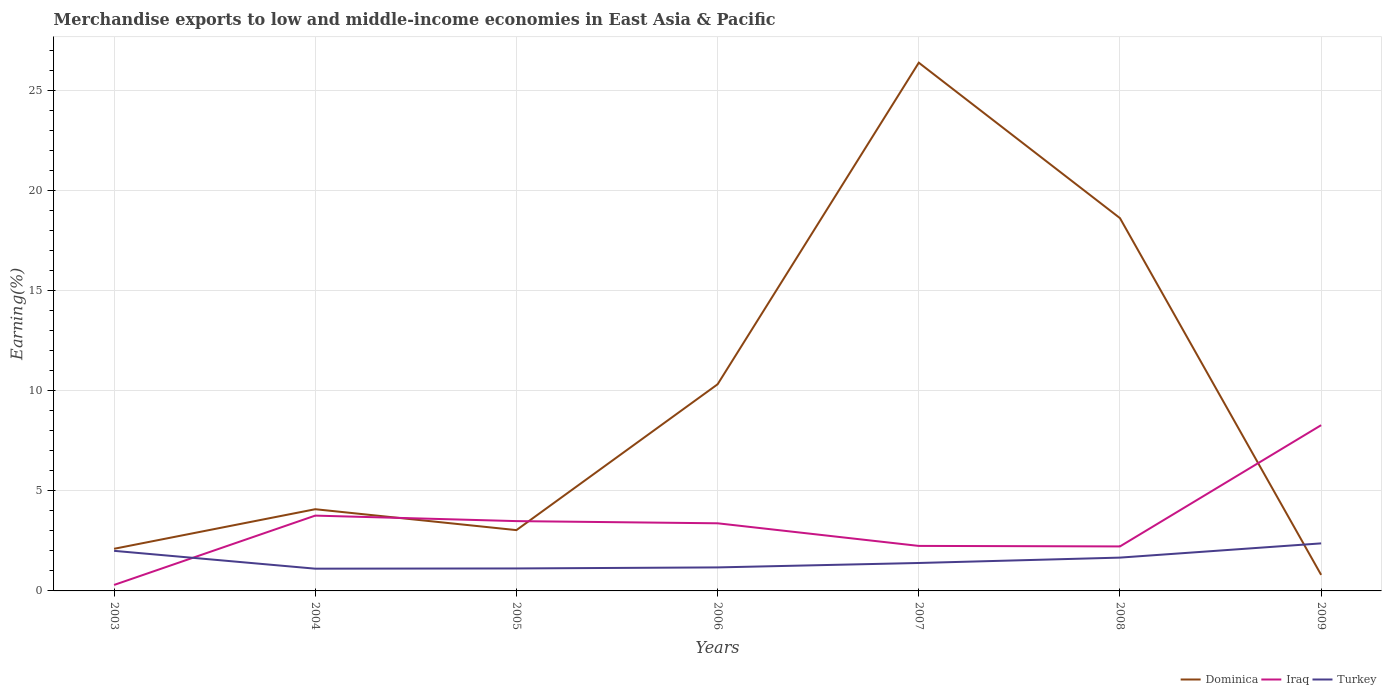Does the line corresponding to Iraq intersect with the line corresponding to Dominica?
Offer a terse response. Yes. Is the number of lines equal to the number of legend labels?
Your answer should be compact. Yes. Across all years, what is the maximum percentage of amount earned from merchandise exports in Turkey?
Your answer should be very brief. 1.11. In which year was the percentage of amount earned from merchandise exports in Iraq maximum?
Ensure brevity in your answer.  2003. What is the total percentage of amount earned from merchandise exports in Dominica in the graph?
Your answer should be very brief. -14.53. What is the difference between the highest and the second highest percentage of amount earned from merchandise exports in Dominica?
Your answer should be very brief. 25.57. What is the difference between the highest and the lowest percentage of amount earned from merchandise exports in Dominica?
Your answer should be very brief. 3. Is the percentage of amount earned from merchandise exports in Iraq strictly greater than the percentage of amount earned from merchandise exports in Turkey over the years?
Your response must be concise. No. How many lines are there?
Ensure brevity in your answer.  3. How many years are there in the graph?
Your response must be concise. 7. What is the difference between two consecutive major ticks on the Y-axis?
Make the answer very short. 5. Where does the legend appear in the graph?
Your answer should be very brief. Bottom right. How are the legend labels stacked?
Your response must be concise. Horizontal. What is the title of the graph?
Your answer should be very brief. Merchandise exports to low and middle-income economies in East Asia & Pacific. What is the label or title of the Y-axis?
Provide a short and direct response. Earning(%). What is the Earning(%) in Dominica in 2003?
Offer a terse response. 2.1. What is the Earning(%) of Iraq in 2003?
Make the answer very short. 0.3. What is the Earning(%) of Turkey in 2003?
Provide a short and direct response. 2. What is the Earning(%) in Dominica in 2004?
Your response must be concise. 4.08. What is the Earning(%) of Iraq in 2004?
Keep it short and to the point. 3.76. What is the Earning(%) of Turkey in 2004?
Your answer should be compact. 1.11. What is the Earning(%) in Dominica in 2005?
Your answer should be compact. 3.04. What is the Earning(%) in Iraq in 2005?
Give a very brief answer. 3.48. What is the Earning(%) of Turkey in 2005?
Offer a very short reply. 1.12. What is the Earning(%) in Dominica in 2006?
Keep it short and to the point. 10.31. What is the Earning(%) in Iraq in 2006?
Offer a very short reply. 3.38. What is the Earning(%) in Turkey in 2006?
Offer a very short reply. 1.17. What is the Earning(%) of Dominica in 2007?
Provide a short and direct response. 26.37. What is the Earning(%) of Iraq in 2007?
Ensure brevity in your answer.  2.25. What is the Earning(%) in Turkey in 2007?
Keep it short and to the point. 1.39. What is the Earning(%) in Dominica in 2008?
Your response must be concise. 18.61. What is the Earning(%) of Iraq in 2008?
Your response must be concise. 2.22. What is the Earning(%) of Turkey in 2008?
Your response must be concise. 1.66. What is the Earning(%) in Dominica in 2009?
Offer a very short reply. 0.8. What is the Earning(%) of Iraq in 2009?
Your response must be concise. 8.27. What is the Earning(%) in Turkey in 2009?
Ensure brevity in your answer.  2.37. Across all years, what is the maximum Earning(%) of Dominica?
Your answer should be very brief. 26.37. Across all years, what is the maximum Earning(%) in Iraq?
Offer a terse response. 8.27. Across all years, what is the maximum Earning(%) in Turkey?
Your response must be concise. 2.37. Across all years, what is the minimum Earning(%) of Dominica?
Your answer should be very brief. 0.8. Across all years, what is the minimum Earning(%) in Iraq?
Your response must be concise. 0.3. Across all years, what is the minimum Earning(%) of Turkey?
Provide a short and direct response. 1.11. What is the total Earning(%) in Dominica in the graph?
Provide a succinct answer. 65.31. What is the total Earning(%) in Iraq in the graph?
Keep it short and to the point. 23.66. What is the total Earning(%) of Turkey in the graph?
Your answer should be compact. 10.84. What is the difference between the Earning(%) of Dominica in 2003 and that in 2004?
Your answer should be very brief. -1.98. What is the difference between the Earning(%) in Iraq in 2003 and that in 2004?
Provide a succinct answer. -3.46. What is the difference between the Earning(%) in Turkey in 2003 and that in 2004?
Provide a short and direct response. 0.89. What is the difference between the Earning(%) of Dominica in 2003 and that in 2005?
Give a very brief answer. -0.93. What is the difference between the Earning(%) in Iraq in 2003 and that in 2005?
Keep it short and to the point. -3.19. What is the difference between the Earning(%) in Turkey in 2003 and that in 2005?
Provide a short and direct response. 0.88. What is the difference between the Earning(%) in Dominica in 2003 and that in 2006?
Provide a short and direct response. -8.21. What is the difference between the Earning(%) of Iraq in 2003 and that in 2006?
Offer a terse response. -3.08. What is the difference between the Earning(%) of Turkey in 2003 and that in 2006?
Offer a very short reply. 0.83. What is the difference between the Earning(%) of Dominica in 2003 and that in 2007?
Your response must be concise. -24.27. What is the difference between the Earning(%) in Iraq in 2003 and that in 2007?
Ensure brevity in your answer.  -1.95. What is the difference between the Earning(%) of Turkey in 2003 and that in 2007?
Ensure brevity in your answer.  0.61. What is the difference between the Earning(%) in Dominica in 2003 and that in 2008?
Provide a short and direct response. -16.51. What is the difference between the Earning(%) of Iraq in 2003 and that in 2008?
Offer a terse response. -1.92. What is the difference between the Earning(%) in Turkey in 2003 and that in 2008?
Ensure brevity in your answer.  0.34. What is the difference between the Earning(%) in Dominica in 2003 and that in 2009?
Keep it short and to the point. 1.3. What is the difference between the Earning(%) in Iraq in 2003 and that in 2009?
Keep it short and to the point. -7.98. What is the difference between the Earning(%) of Turkey in 2003 and that in 2009?
Offer a terse response. -0.37. What is the difference between the Earning(%) in Dominica in 2004 and that in 2005?
Your answer should be compact. 1.04. What is the difference between the Earning(%) in Iraq in 2004 and that in 2005?
Make the answer very short. 0.28. What is the difference between the Earning(%) in Turkey in 2004 and that in 2005?
Your answer should be very brief. -0.01. What is the difference between the Earning(%) in Dominica in 2004 and that in 2006?
Give a very brief answer. -6.24. What is the difference between the Earning(%) in Iraq in 2004 and that in 2006?
Your response must be concise. 0.38. What is the difference between the Earning(%) of Turkey in 2004 and that in 2006?
Keep it short and to the point. -0.06. What is the difference between the Earning(%) in Dominica in 2004 and that in 2007?
Make the answer very short. -22.29. What is the difference between the Earning(%) in Iraq in 2004 and that in 2007?
Provide a short and direct response. 1.51. What is the difference between the Earning(%) in Turkey in 2004 and that in 2007?
Make the answer very short. -0.28. What is the difference between the Earning(%) of Dominica in 2004 and that in 2008?
Your response must be concise. -14.53. What is the difference between the Earning(%) in Iraq in 2004 and that in 2008?
Give a very brief answer. 1.54. What is the difference between the Earning(%) in Turkey in 2004 and that in 2008?
Keep it short and to the point. -0.55. What is the difference between the Earning(%) of Dominica in 2004 and that in 2009?
Your answer should be compact. 3.28. What is the difference between the Earning(%) in Iraq in 2004 and that in 2009?
Keep it short and to the point. -4.51. What is the difference between the Earning(%) of Turkey in 2004 and that in 2009?
Give a very brief answer. -1.26. What is the difference between the Earning(%) of Dominica in 2005 and that in 2006?
Ensure brevity in your answer.  -7.28. What is the difference between the Earning(%) of Iraq in 2005 and that in 2006?
Give a very brief answer. 0.11. What is the difference between the Earning(%) in Turkey in 2005 and that in 2006?
Provide a succinct answer. -0.05. What is the difference between the Earning(%) of Dominica in 2005 and that in 2007?
Give a very brief answer. -23.33. What is the difference between the Earning(%) of Iraq in 2005 and that in 2007?
Keep it short and to the point. 1.24. What is the difference between the Earning(%) of Turkey in 2005 and that in 2007?
Offer a very short reply. -0.27. What is the difference between the Earning(%) of Dominica in 2005 and that in 2008?
Provide a succinct answer. -15.57. What is the difference between the Earning(%) in Iraq in 2005 and that in 2008?
Provide a short and direct response. 1.26. What is the difference between the Earning(%) of Turkey in 2005 and that in 2008?
Offer a terse response. -0.54. What is the difference between the Earning(%) in Dominica in 2005 and that in 2009?
Your answer should be very brief. 2.23. What is the difference between the Earning(%) of Iraq in 2005 and that in 2009?
Ensure brevity in your answer.  -4.79. What is the difference between the Earning(%) of Turkey in 2005 and that in 2009?
Provide a short and direct response. -1.25. What is the difference between the Earning(%) in Dominica in 2006 and that in 2007?
Provide a short and direct response. -16.05. What is the difference between the Earning(%) of Iraq in 2006 and that in 2007?
Ensure brevity in your answer.  1.13. What is the difference between the Earning(%) in Turkey in 2006 and that in 2007?
Offer a terse response. -0.22. What is the difference between the Earning(%) of Dominica in 2006 and that in 2008?
Make the answer very short. -8.29. What is the difference between the Earning(%) in Iraq in 2006 and that in 2008?
Your response must be concise. 1.15. What is the difference between the Earning(%) in Turkey in 2006 and that in 2008?
Your answer should be compact. -0.49. What is the difference between the Earning(%) of Dominica in 2006 and that in 2009?
Offer a terse response. 9.51. What is the difference between the Earning(%) in Iraq in 2006 and that in 2009?
Keep it short and to the point. -4.9. What is the difference between the Earning(%) of Turkey in 2006 and that in 2009?
Your answer should be compact. -1.2. What is the difference between the Earning(%) in Dominica in 2007 and that in 2008?
Make the answer very short. 7.76. What is the difference between the Earning(%) of Iraq in 2007 and that in 2008?
Your response must be concise. 0.03. What is the difference between the Earning(%) of Turkey in 2007 and that in 2008?
Ensure brevity in your answer.  -0.27. What is the difference between the Earning(%) of Dominica in 2007 and that in 2009?
Provide a succinct answer. 25.57. What is the difference between the Earning(%) in Iraq in 2007 and that in 2009?
Keep it short and to the point. -6.03. What is the difference between the Earning(%) in Turkey in 2007 and that in 2009?
Provide a short and direct response. -0.98. What is the difference between the Earning(%) in Dominica in 2008 and that in 2009?
Your answer should be very brief. 17.81. What is the difference between the Earning(%) of Iraq in 2008 and that in 2009?
Ensure brevity in your answer.  -6.05. What is the difference between the Earning(%) in Turkey in 2008 and that in 2009?
Your answer should be very brief. -0.71. What is the difference between the Earning(%) of Dominica in 2003 and the Earning(%) of Iraq in 2004?
Keep it short and to the point. -1.66. What is the difference between the Earning(%) in Iraq in 2003 and the Earning(%) in Turkey in 2004?
Offer a terse response. -0.81. What is the difference between the Earning(%) of Dominica in 2003 and the Earning(%) of Iraq in 2005?
Provide a succinct answer. -1.38. What is the difference between the Earning(%) of Dominica in 2003 and the Earning(%) of Turkey in 2005?
Make the answer very short. 0.98. What is the difference between the Earning(%) in Iraq in 2003 and the Earning(%) in Turkey in 2005?
Ensure brevity in your answer.  -0.82. What is the difference between the Earning(%) in Dominica in 2003 and the Earning(%) in Iraq in 2006?
Provide a short and direct response. -1.27. What is the difference between the Earning(%) in Dominica in 2003 and the Earning(%) in Turkey in 2006?
Your answer should be very brief. 0.93. What is the difference between the Earning(%) in Iraq in 2003 and the Earning(%) in Turkey in 2006?
Give a very brief answer. -0.88. What is the difference between the Earning(%) of Dominica in 2003 and the Earning(%) of Iraq in 2007?
Offer a very short reply. -0.14. What is the difference between the Earning(%) in Dominica in 2003 and the Earning(%) in Turkey in 2007?
Ensure brevity in your answer.  0.71. What is the difference between the Earning(%) in Iraq in 2003 and the Earning(%) in Turkey in 2007?
Ensure brevity in your answer.  -1.1. What is the difference between the Earning(%) in Dominica in 2003 and the Earning(%) in Iraq in 2008?
Provide a short and direct response. -0.12. What is the difference between the Earning(%) of Dominica in 2003 and the Earning(%) of Turkey in 2008?
Ensure brevity in your answer.  0.44. What is the difference between the Earning(%) in Iraq in 2003 and the Earning(%) in Turkey in 2008?
Your response must be concise. -1.36. What is the difference between the Earning(%) of Dominica in 2003 and the Earning(%) of Iraq in 2009?
Make the answer very short. -6.17. What is the difference between the Earning(%) in Dominica in 2003 and the Earning(%) in Turkey in 2009?
Provide a succinct answer. -0.27. What is the difference between the Earning(%) in Iraq in 2003 and the Earning(%) in Turkey in 2009?
Offer a terse response. -2.08. What is the difference between the Earning(%) of Dominica in 2004 and the Earning(%) of Iraq in 2005?
Provide a short and direct response. 0.59. What is the difference between the Earning(%) in Dominica in 2004 and the Earning(%) in Turkey in 2005?
Your answer should be compact. 2.96. What is the difference between the Earning(%) of Iraq in 2004 and the Earning(%) of Turkey in 2005?
Your answer should be compact. 2.64. What is the difference between the Earning(%) of Dominica in 2004 and the Earning(%) of Iraq in 2006?
Provide a short and direct response. 0.7. What is the difference between the Earning(%) in Dominica in 2004 and the Earning(%) in Turkey in 2006?
Your answer should be compact. 2.9. What is the difference between the Earning(%) in Iraq in 2004 and the Earning(%) in Turkey in 2006?
Provide a short and direct response. 2.59. What is the difference between the Earning(%) of Dominica in 2004 and the Earning(%) of Iraq in 2007?
Provide a succinct answer. 1.83. What is the difference between the Earning(%) in Dominica in 2004 and the Earning(%) in Turkey in 2007?
Offer a very short reply. 2.68. What is the difference between the Earning(%) in Iraq in 2004 and the Earning(%) in Turkey in 2007?
Keep it short and to the point. 2.37. What is the difference between the Earning(%) of Dominica in 2004 and the Earning(%) of Iraq in 2008?
Make the answer very short. 1.86. What is the difference between the Earning(%) in Dominica in 2004 and the Earning(%) in Turkey in 2008?
Give a very brief answer. 2.42. What is the difference between the Earning(%) in Iraq in 2004 and the Earning(%) in Turkey in 2008?
Provide a short and direct response. 2.1. What is the difference between the Earning(%) in Dominica in 2004 and the Earning(%) in Iraq in 2009?
Offer a very short reply. -4.2. What is the difference between the Earning(%) in Dominica in 2004 and the Earning(%) in Turkey in 2009?
Make the answer very short. 1.71. What is the difference between the Earning(%) in Iraq in 2004 and the Earning(%) in Turkey in 2009?
Your answer should be compact. 1.39. What is the difference between the Earning(%) in Dominica in 2005 and the Earning(%) in Iraq in 2006?
Your answer should be compact. -0.34. What is the difference between the Earning(%) of Dominica in 2005 and the Earning(%) of Turkey in 2006?
Offer a very short reply. 1.86. What is the difference between the Earning(%) in Iraq in 2005 and the Earning(%) in Turkey in 2006?
Your response must be concise. 2.31. What is the difference between the Earning(%) in Dominica in 2005 and the Earning(%) in Iraq in 2007?
Give a very brief answer. 0.79. What is the difference between the Earning(%) in Dominica in 2005 and the Earning(%) in Turkey in 2007?
Keep it short and to the point. 1.64. What is the difference between the Earning(%) in Iraq in 2005 and the Earning(%) in Turkey in 2007?
Provide a succinct answer. 2.09. What is the difference between the Earning(%) of Dominica in 2005 and the Earning(%) of Iraq in 2008?
Make the answer very short. 0.81. What is the difference between the Earning(%) in Dominica in 2005 and the Earning(%) in Turkey in 2008?
Give a very brief answer. 1.37. What is the difference between the Earning(%) in Iraq in 2005 and the Earning(%) in Turkey in 2008?
Keep it short and to the point. 1.82. What is the difference between the Earning(%) in Dominica in 2005 and the Earning(%) in Iraq in 2009?
Make the answer very short. -5.24. What is the difference between the Earning(%) in Dominica in 2005 and the Earning(%) in Turkey in 2009?
Make the answer very short. 0.66. What is the difference between the Earning(%) in Iraq in 2005 and the Earning(%) in Turkey in 2009?
Your response must be concise. 1.11. What is the difference between the Earning(%) in Dominica in 2006 and the Earning(%) in Iraq in 2007?
Your answer should be compact. 8.07. What is the difference between the Earning(%) of Dominica in 2006 and the Earning(%) of Turkey in 2007?
Keep it short and to the point. 8.92. What is the difference between the Earning(%) in Iraq in 2006 and the Earning(%) in Turkey in 2007?
Provide a short and direct response. 1.98. What is the difference between the Earning(%) in Dominica in 2006 and the Earning(%) in Iraq in 2008?
Offer a terse response. 8.09. What is the difference between the Earning(%) in Dominica in 2006 and the Earning(%) in Turkey in 2008?
Give a very brief answer. 8.65. What is the difference between the Earning(%) in Iraq in 2006 and the Earning(%) in Turkey in 2008?
Your answer should be very brief. 1.71. What is the difference between the Earning(%) of Dominica in 2006 and the Earning(%) of Iraq in 2009?
Ensure brevity in your answer.  2.04. What is the difference between the Earning(%) in Dominica in 2006 and the Earning(%) in Turkey in 2009?
Your response must be concise. 7.94. What is the difference between the Earning(%) in Dominica in 2007 and the Earning(%) in Iraq in 2008?
Provide a succinct answer. 24.15. What is the difference between the Earning(%) of Dominica in 2007 and the Earning(%) of Turkey in 2008?
Offer a terse response. 24.71. What is the difference between the Earning(%) of Iraq in 2007 and the Earning(%) of Turkey in 2008?
Your answer should be very brief. 0.58. What is the difference between the Earning(%) of Dominica in 2007 and the Earning(%) of Iraq in 2009?
Your answer should be compact. 18.09. What is the difference between the Earning(%) of Dominica in 2007 and the Earning(%) of Turkey in 2009?
Provide a short and direct response. 24. What is the difference between the Earning(%) in Iraq in 2007 and the Earning(%) in Turkey in 2009?
Your answer should be very brief. -0.13. What is the difference between the Earning(%) in Dominica in 2008 and the Earning(%) in Iraq in 2009?
Offer a terse response. 10.34. What is the difference between the Earning(%) in Dominica in 2008 and the Earning(%) in Turkey in 2009?
Give a very brief answer. 16.24. What is the difference between the Earning(%) of Iraq in 2008 and the Earning(%) of Turkey in 2009?
Make the answer very short. -0.15. What is the average Earning(%) of Dominica per year?
Offer a terse response. 9.33. What is the average Earning(%) of Iraq per year?
Ensure brevity in your answer.  3.38. What is the average Earning(%) of Turkey per year?
Give a very brief answer. 1.55. In the year 2003, what is the difference between the Earning(%) in Dominica and Earning(%) in Iraq?
Provide a short and direct response. 1.81. In the year 2003, what is the difference between the Earning(%) in Dominica and Earning(%) in Turkey?
Your answer should be compact. 0.1. In the year 2003, what is the difference between the Earning(%) in Iraq and Earning(%) in Turkey?
Offer a terse response. -1.7. In the year 2004, what is the difference between the Earning(%) in Dominica and Earning(%) in Iraq?
Provide a short and direct response. 0.32. In the year 2004, what is the difference between the Earning(%) of Dominica and Earning(%) of Turkey?
Keep it short and to the point. 2.97. In the year 2004, what is the difference between the Earning(%) of Iraq and Earning(%) of Turkey?
Offer a very short reply. 2.65. In the year 2005, what is the difference between the Earning(%) in Dominica and Earning(%) in Iraq?
Keep it short and to the point. -0.45. In the year 2005, what is the difference between the Earning(%) of Dominica and Earning(%) of Turkey?
Ensure brevity in your answer.  1.91. In the year 2005, what is the difference between the Earning(%) in Iraq and Earning(%) in Turkey?
Keep it short and to the point. 2.36. In the year 2006, what is the difference between the Earning(%) of Dominica and Earning(%) of Iraq?
Keep it short and to the point. 6.94. In the year 2006, what is the difference between the Earning(%) in Dominica and Earning(%) in Turkey?
Provide a succinct answer. 9.14. In the year 2006, what is the difference between the Earning(%) of Iraq and Earning(%) of Turkey?
Provide a short and direct response. 2.2. In the year 2007, what is the difference between the Earning(%) of Dominica and Earning(%) of Iraq?
Give a very brief answer. 24.12. In the year 2007, what is the difference between the Earning(%) of Dominica and Earning(%) of Turkey?
Offer a terse response. 24.97. In the year 2007, what is the difference between the Earning(%) in Iraq and Earning(%) in Turkey?
Your answer should be compact. 0.85. In the year 2008, what is the difference between the Earning(%) in Dominica and Earning(%) in Iraq?
Your answer should be very brief. 16.39. In the year 2008, what is the difference between the Earning(%) of Dominica and Earning(%) of Turkey?
Your answer should be compact. 16.95. In the year 2008, what is the difference between the Earning(%) of Iraq and Earning(%) of Turkey?
Keep it short and to the point. 0.56. In the year 2009, what is the difference between the Earning(%) of Dominica and Earning(%) of Iraq?
Your answer should be very brief. -7.47. In the year 2009, what is the difference between the Earning(%) of Dominica and Earning(%) of Turkey?
Your response must be concise. -1.57. In the year 2009, what is the difference between the Earning(%) in Iraq and Earning(%) in Turkey?
Ensure brevity in your answer.  5.9. What is the ratio of the Earning(%) in Dominica in 2003 to that in 2004?
Ensure brevity in your answer.  0.52. What is the ratio of the Earning(%) of Iraq in 2003 to that in 2004?
Provide a succinct answer. 0.08. What is the ratio of the Earning(%) in Turkey in 2003 to that in 2004?
Offer a terse response. 1.8. What is the ratio of the Earning(%) of Dominica in 2003 to that in 2005?
Your answer should be very brief. 0.69. What is the ratio of the Earning(%) in Iraq in 2003 to that in 2005?
Ensure brevity in your answer.  0.09. What is the ratio of the Earning(%) of Turkey in 2003 to that in 2005?
Offer a terse response. 1.78. What is the ratio of the Earning(%) in Dominica in 2003 to that in 2006?
Make the answer very short. 0.2. What is the ratio of the Earning(%) in Iraq in 2003 to that in 2006?
Keep it short and to the point. 0.09. What is the ratio of the Earning(%) in Turkey in 2003 to that in 2006?
Give a very brief answer. 1.71. What is the ratio of the Earning(%) of Dominica in 2003 to that in 2007?
Your answer should be very brief. 0.08. What is the ratio of the Earning(%) of Iraq in 2003 to that in 2007?
Make the answer very short. 0.13. What is the ratio of the Earning(%) in Turkey in 2003 to that in 2007?
Offer a very short reply. 1.44. What is the ratio of the Earning(%) in Dominica in 2003 to that in 2008?
Your answer should be compact. 0.11. What is the ratio of the Earning(%) of Iraq in 2003 to that in 2008?
Provide a short and direct response. 0.13. What is the ratio of the Earning(%) in Turkey in 2003 to that in 2008?
Offer a very short reply. 1.2. What is the ratio of the Earning(%) in Dominica in 2003 to that in 2009?
Your response must be concise. 2.63. What is the ratio of the Earning(%) in Iraq in 2003 to that in 2009?
Your response must be concise. 0.04. What is the ratio of the Earning(%) in Turkey in 2003 to that in 2009?
Make the answer very short. 0.84. What is the ratio of the Earning(%) of Dominica in 2004 to that in 2005?
Your answer should be compact. 1.34. What is the ratio of the Earning(%) in Iraq in 2004 to that in 2005?
Offer a terse response. 1.08. What is the ratio of the Earning(%) in Dominica in 2004 to that in 2006?
Provide a short and direct response. 0.4. What is the ratio of the Earning(%) of Iraq in 2004 to that in 2006?
Your answer should be compact. 1.11. What is the ratio of the Earning(%) of Turkey in 2004 to that in 2006?
Offer a terse response. 0.95. What is the ratio of the Earning(%) of Dominica in 2004 to that in 2007?
Offer a terse response. 0.15. What is the ratio of the Earning(%) of Iraq in 2004 to that in 2007?
Offer a terse response. 1.67. What is the ratio of the Earning(%) in Turkey in 2004 to that in 2007?
Provide a short and direct response. 0.8. What is the ratio of the Earning(%) in Dominica in 2004 to that in 2008?
Ensure brevity in your answer.  0.22. What is the ratio of the Earning(%) of Iraq in 2004 to that in 2008?
Keep it short and to the point. 1.69. What is the ratio of the Earning(%) of Turkey in 2004 to that in 2008?
Offer a very short reply. 0.67. What is the ratio of the Earning(%) in Dominica in 2004 to that in 2009?
Provide a succinct answer. 5.09. What is the ratio of the Earning(%) in Iraq in 2004 to that in 2009?
Make the answer very short. 0.45. What is the ratio of the Earning(%) of Turkey in 2004 to that in 2009?
Ensure brevity in your answer.  0.47. What is the ratio of the Earning(%) in Dominica in 2005 to that in 2006?
Your answer should be compact. 0.29. What is the ratio of the Earning(%) of Iraq in 2005 to that in 2006?
Your response must be concise. 1.03. What is the ratio of the Earning(%) in Turkey in 2005 to that in 2006?
Provide a short and direct response. 0.96. What is the ratio of the Earning(%) in Dominica in 2005 to that in 2007?
Your answer should be compact. 0.12. What is the ratio of the Earning(%) in Iraq in 2005 to that in 2007?
Give a very brief answer. 1.55. What is the ratio of the Earning(%) of Turkey in 2005 to that in 2007?
Give a very brief answer. 0.8. What is the ratio of the Earning(%) of Dominica in 2005 to that in 2008?
Your answer should be compact. 0.16. What is the ratio of the Earning(%) of Iraq in 2005 to that in 2008?
Your response must be concise. 1.57. What is the ratio of the Earning(%) of Turkey in 2005 to that in 2008?
Offer a very short reply. 0.67. What is the ratio of the Earning(%) of Dominica in 2005 to that in 2009?
Your response must be concise. 3.79. What is the ratio of the Earning(%) in Iraq in 2005 to that in 2009?
Provide a short and direct response. 0.42. What is the ratio of the Earning(%) in Turkey in 2005 to that in 2009?
Your answer should be compact. 0.47. What is the ratio of the Earning(%) of Dominica in 2006 to that in 2007?
Make the answer very short. 0.39. What is the ratio of the Earning(%) in Iraq in 2006 to that in 2007?
Give a very brief answer. 1.5. What is the ratio of the Earning(%) of Turkey in 2006 to that in 2007?
Ensure brevity in your answer.  0.84. What is the ratio of the Earning(%) in Dominica in 2006 to that in 2008?
Provide a succinct answer. 0.55. What is the ratio of the Earning(%) in Iraq in 2006 to that in 2008?
Make the answer very short. 1.52. What is the ratio of the Earning(%) of Turkey in 2006 to that in 2008?
Provide a short and direct response. 0.71. What is the ratio of the Earning(%) of Dominica in 2006 to that in 2009?
Make the answer very short. 12.88. What is the ratio of the Earning(%) of Iraq in 2006 to that in 2009?
Offer a terse response. 0.41. What is the ratio of the Earning(%) in Turkey in 2006 to that in 2009?
Provide a short and direct response. 0.49. What is the ratio of the Earning(%) in Dominica in 2007 to that in 2008?
Your answer should be compact. 1.42. What is the ratio of the Earning(%) in Iraq in 2007 to that in 2008?
Your answer should be compact. 1.01. What is the ratio of the Earning(%) of Turkey in 2007 to that in 2008?
Make the answer very short. 0.84. What is the ratio of the Earning(%) of Dominica in 2007 to that in 2009?
Offer a very short reply. 32.92. What is the ratio of the Earning(%) in Iraq in 2007 to that in 2009?
Offer a terse response. 0.27. What is the ratio of the Earning(%) in Turkey in 2007 to that in 2009?
Your answer should be very brief. 0.59. What is the ratio of the Earning(%) in Dominica in 2008 to that in 2009?
Provide a short and direct response. 23.24. What is the ratio of the Earning(%) in Iraq in 2008 to that in 2009?
Your answer should be very brief. 0.27. What is the ratio of the Earning(%) of Turkey in 2008 to that in 2009?
Offer a very short reply. 0.7. What is the difference between the highest and the second highest Earning(%) in Dominica?
Give a very brief answer. 7.76. What is the difference between the highest and the second highest Earning(%) of Iraq?
Your answer should be compact. 4.51. What is the difference between the highest and the second highest Earning(%) in Turkey?
Provide a short and direct response. 0.37. What is the difference between the highest and the lowest Earning(%) of Dominica?
Your answer should be very brief. 25.57. What is the difference between the highest and the lowest Earning(%) of Iraq?
Your answer should be very brief. 7.98. What is the difference between the highest and the lowest Earning(%) in Turkey?
Offer a very short reply. 1.26. 